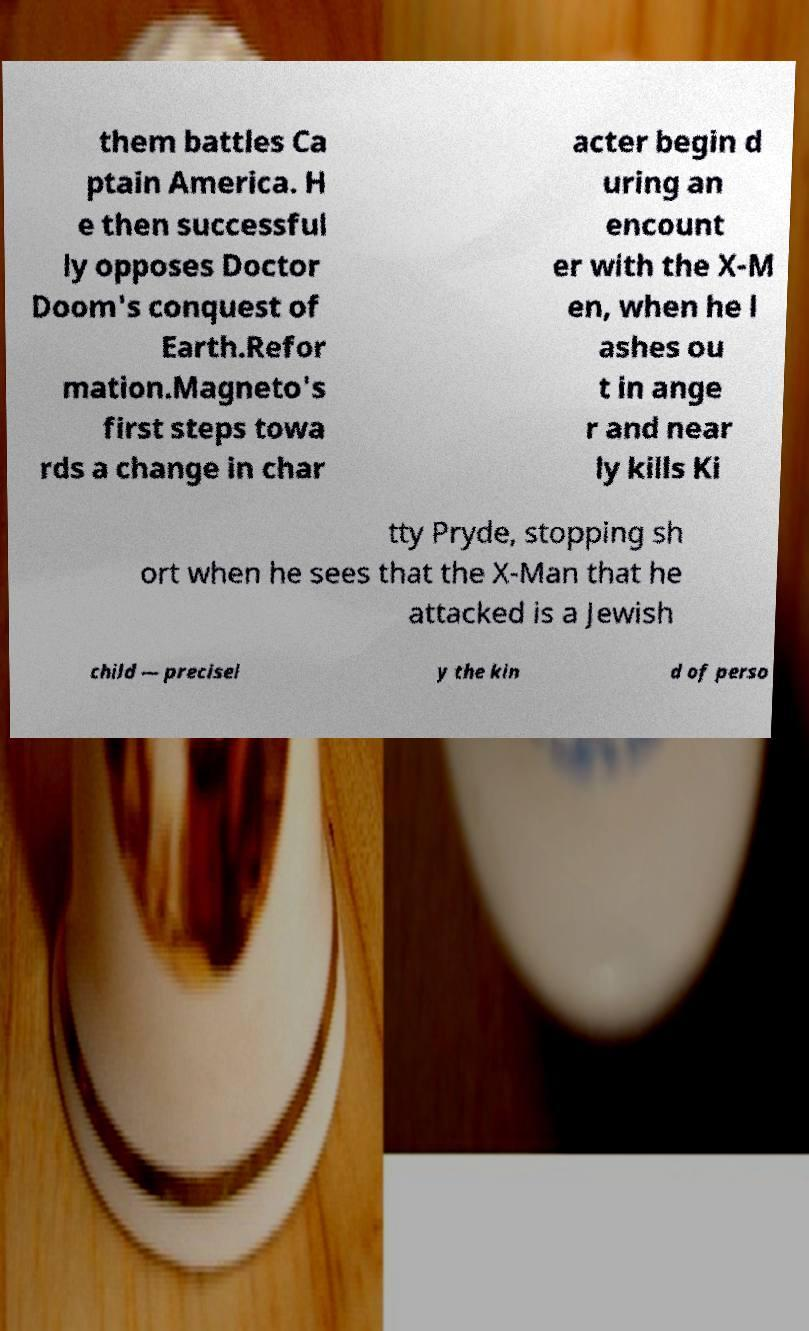There's text embedded in this image that I need extracted. Can you transcribe it verbatim? them battles Ca ptain America. H e then successful ly opposes Doctor Doom's conquest of Earth.Refor mation.Magneto's first steps towa rds a change in char acter begin d uring an encount er with the X-M en, when he l ashes ou t in ange r and near ly kills Ki tty Pryde, stopping sh ort when he sees that the X-Man that he attacked is a Jewish child — precisel y the kin d of perso 